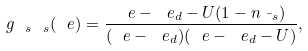<formula> <loc_0><loc_0><loc_500><loc_500>g _ { \ s \ s } ( \ e ) = \frac { \ e - \ e _ { d } - U ( 1 - n _ { \bar { \ s } } ) } { ( \ e - \ e _ { d } ) ( \ e - \ e _ { d } - U ) } ,</formula> 